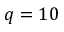Convert formula to latex. <formula><loc_0><loc_0><loc_500><loc_500>q = 1 0</formula> 